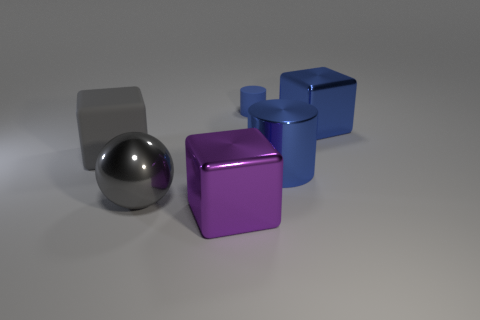Are there any other things that have the same size as the blue rubber thing?
Your response must be concise. No. What is the material of the cylinder that is the same color as the tiny rubber thing?
Make the answer very short. Metal. Do the shiny object that is left of the big purple shiny cube and the tiny rubber thing have the same shape?
Keep it short and to the point. No. How many objects are either tiny matte cylinders or big blue blocks?
Offer a very short reply. 2. Are the cube that is in front of the gray metal thing and the large blue cylinder made of the same material?
Your answer should be compact. Yes. The matte cube is what size?
Provide a succinct answer. Large. There is a object that is the same color as the big metallic sphere; what is its shape?
Your answer should be compact. Cube. How many balls are either gray matte objects or purple things?
Provide a short and direct response. 0. Are there the same number of gray matte things that are in front of the large sphere and cubes that are to the left of the big blue metal cube?
Offer a terse response. No. There is a blue metallic object that is the same shape as the blue rubber object; what is its size?
Provide a short and direct response. Large. 